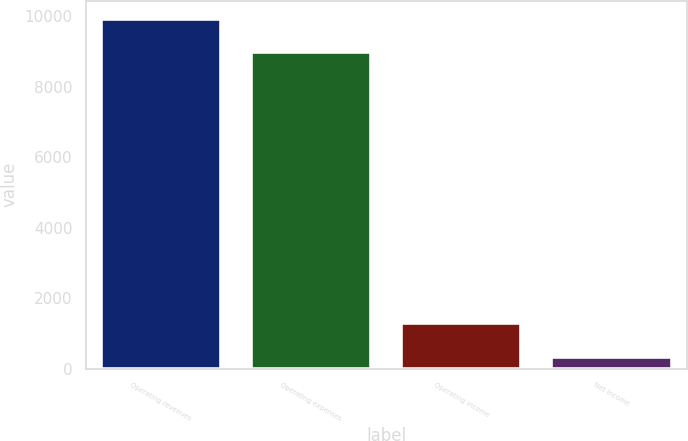Convert chart to OTSL. <chart><loc_0><loc_0><loc_500><loc_500><bar_chart><fcel>Operating revenues<fcel>Operating expenses<fcel>Operating income<fcel>Net income<nl><fcel>9939.5<fcel>8995<fcel>1285.5<fcel>341<nl></chart> 